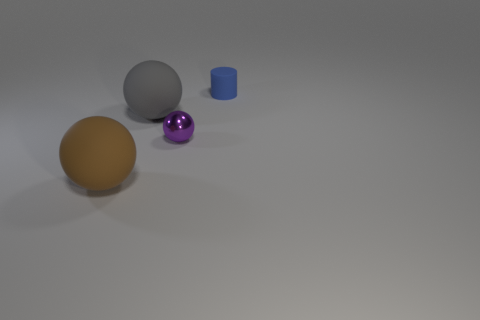How many things are tiny objects that are behind the tiny metallic object or small things to the left of the small blue cylinder?
Your answer should be compact. 2. Are there fewer gray spheres to the right of the big brown thing than tiny cyan spheres?
Keep it short and to the point. No. Does the blue object have the same material as the large brown thing on the left side of the large gray matte sphere?
Offer a very short reply. Yes. What is the brown object made of?
Keep it short and to the point. Rubber. What material is the sphere behind the tiny object in front of the tiny thing behind the gray thing made of?
Provide a short and direct response. Rubber. Do the cylinder and the large rubber ball that is behind the large brown matte sphere have the same color?
Offer a very short reply. No. Is there anything else that is the same shape as the brown rubber object?
Provide a succinct answer. Yes. The big object that is on the right side of the rubber sphere in front of the purple metal ball is what color?
Provide a succinct answer. Gray. How many tiny shiny spheres are there?
Provide a succinct answer. 1. What number of matte objects are either small purple things or tiny red cubes?
Your response must be concise. 0. 